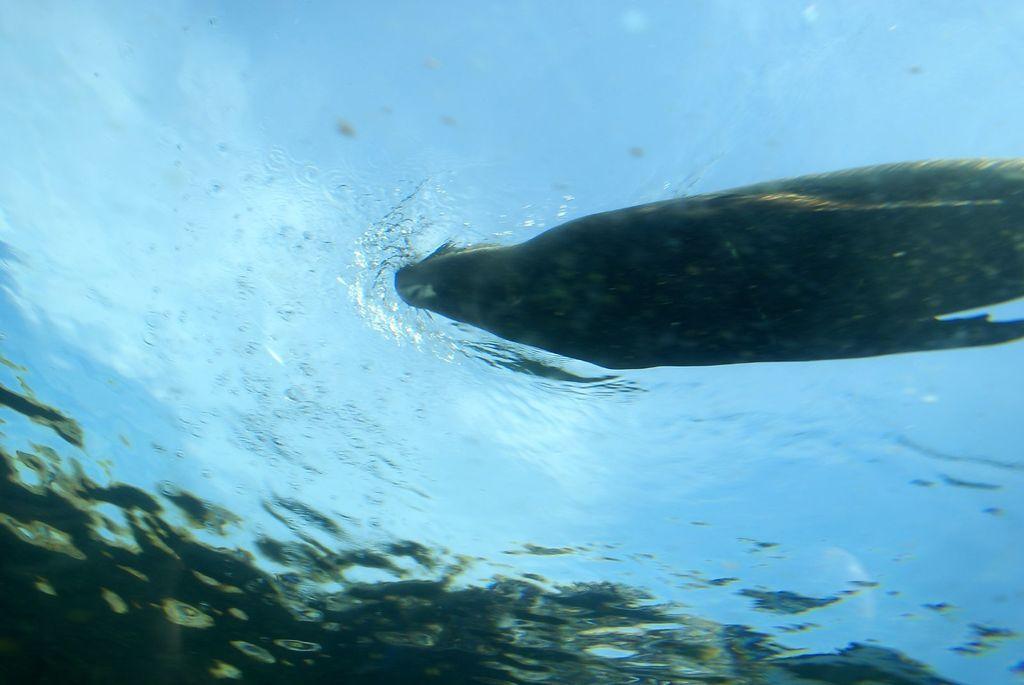Can you describe this image briefly? In this picture there is a seal in water and there are few fishes below it. 